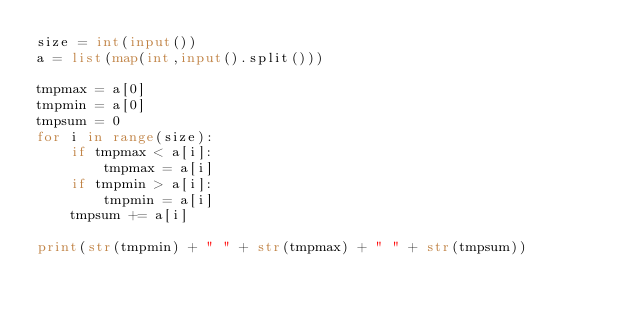<code> <loc_0><loc_0><loc_500><loc_500><_Python_>size = int(input())
a = list(map(int,input().split()))

tmpmax = a[0]
tmpmin = a[0]
tmpsum = 0
for i in range(size):
    if tmpmax < a[i]:
        tmpmax = a[i]
    if tmpmin > a[i]:
        tmpmin = a[i]
    tmpsum += a[i]
    
print(str(tmpmin) + " " + str(tmpmax) + " " + str(tmpsum))

</code> 